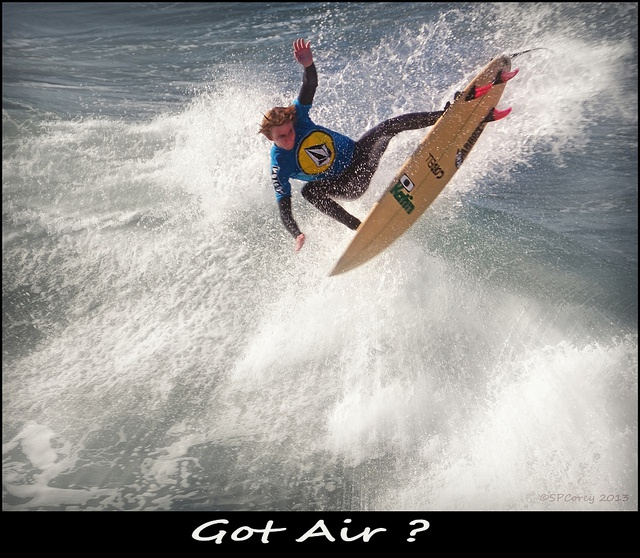Describe the objects in this image and their specific colors. I can see people in black, gray, lightgray, and darkgray tones and surfboard in black, gray, tan, and brown tones in this image. 